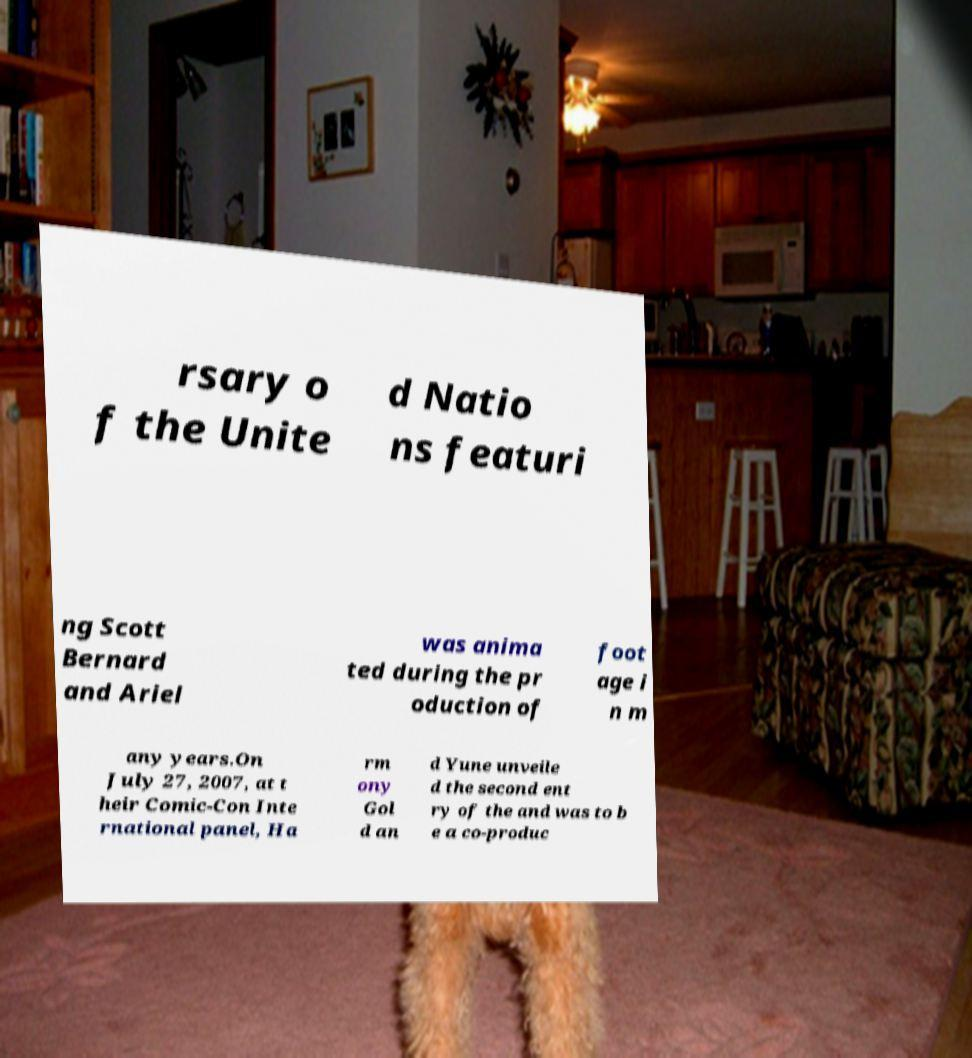Could you assist in decoding the text presented in this image and type it out clearly? rsary o f the Unite d Natio ns featuri ng Scott Bernard and Ariel was anima ted during the pr oduction of foot age i n m any years.On July 27, 2007, at t heir Comic-Con Inte rnational panel, Ha rm ony Gol d an d Yune unveile d the second ent ry of the and was to b e a co-produc 